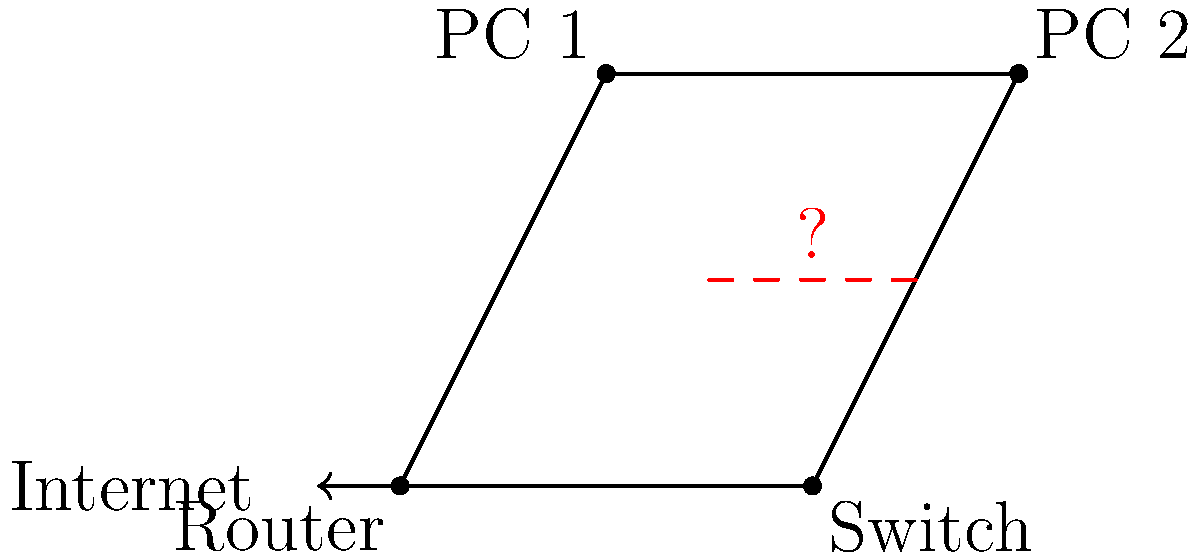In the network topology diagram shown, there appears to be a connection issue between PC 1 and PC 2. What is the most likely cause of this problem, and how would you troubleshoot it as a computer technician? To troubleshoot this network issue, follow these steps:

1. Analyze the network topology:
   - The diagram shows a basic star topology with a central switch.
   - The router connects the network to the internet.
   - PC 1 and PC 2 are connected to the switch.

2. Identify the problem:
   - The red dashed line between PC 1 and PC 2 indicates a connection issue.

3. Consider possible causes:
   - Switch malfunction
   - Faulty network cables
   - Incorrect IP configuration on PCs
   - Network interface card (NIC) issues

4. Troubleshooting steps:
   a. Check physical connections:
      - Ensure all cables are properly connected to the switch and PCs.
      - Inspect cables for damage and replace if necessary.

   b. Verify switch functionality:
      - Check switch status lights for any indication of port issues.
      - Try connecting PCs to different switch ports.

   c. Test network connectivity:
      - Use the "ping" command from each PC to test connectivity to the switch and router.
      - If pings to the switch/router succeed but PC-to-PC fails, focus on PC configurations.

   d. Check IP configurations:
      - Ensure both PCs are on the same subnet.
      - Verify IP addresses, subnet masks, and default gateways are correct.

   e. Examine NIC settings:
      - Check NIC status in Device Manager.
      - Update or reinstall NIC drivers if necessary.

5. Most likely cause:
   Given that it's a basic network setup and the issue is specific to PC-to-PC communication, the most probable cause is an incorrect IP configuration on one or both PCs.

6. Resolution:
   Verify and correct the IP settings on both PCs to ensure they are on the same subnet and can communicate directly.
Answer: Incorrect IP configuration 